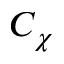<formula> <loc_0><loc_0><loc_500><loc_500>C _ { \chi }</formula> 